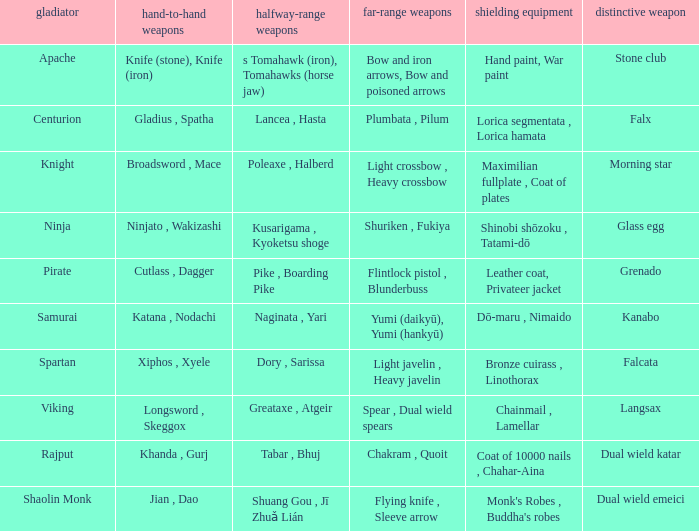If the special weapon is the Grenado, what is the armor? Leather coat, Privateer jacket. 